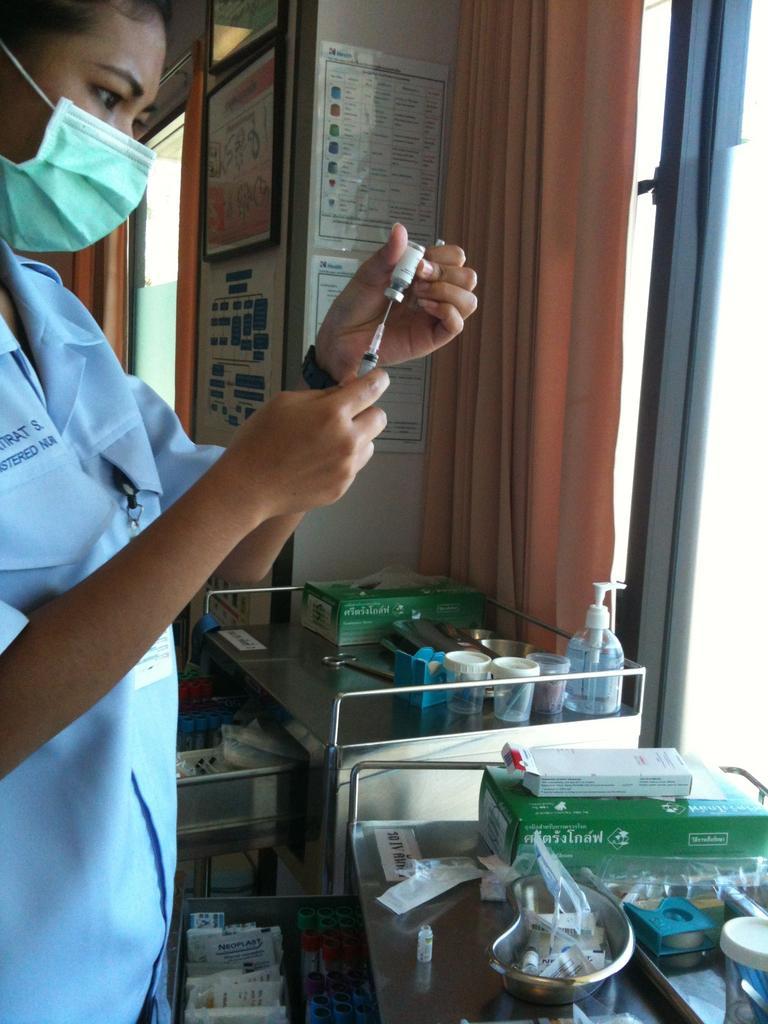How would you summarize this image in a sentence or two? In this image on the left side there is one person standing, and she is wearing a mask and she is holding an injection and in front of her there are tables. On the tables are some boxes, bottles, cups and objects. In the background there are some boards, curtain and wall. 